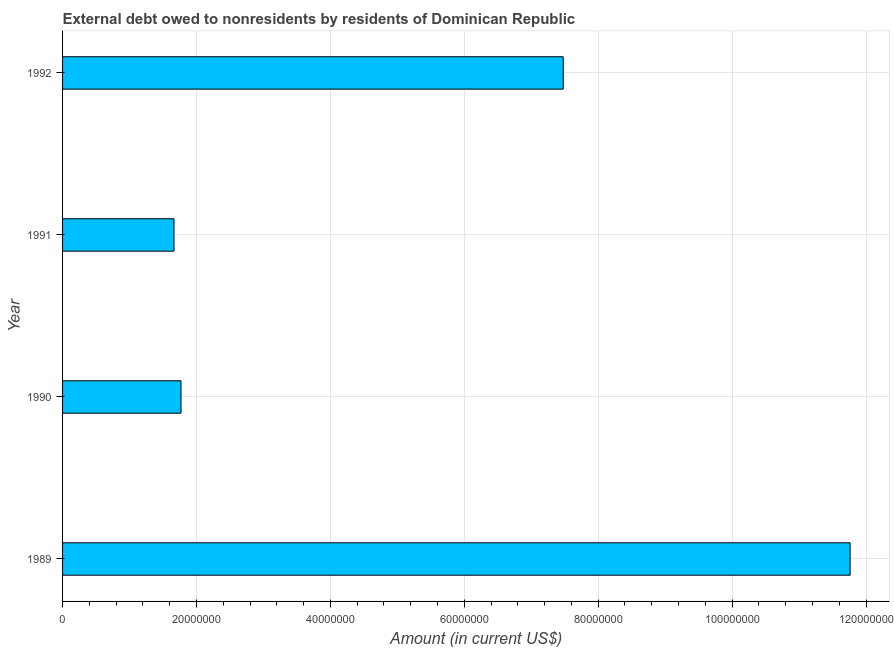Does the graph contain any zero values?
Offer a very short reply. No. Does the graph contain grids?
Offer a terse response. Yes. What is the title of the graph?
Offer a terse response. External debt owed to nonresidents by residents of Dominican Republic. What is the label or title of the X-axis?
Your answer should be compact. Amount (in current US$). What is the label or title of the Y-axis?
Provide a succinct answer. Year. What is the debt in 1989?
Your response must be concise. 1.18e+08. Across all years, what is the maximum debt?
Keep it short and to the point. 1.18e+08. Across all years, what is the minimum debt?
Your answer should be compact. 1.66e+07. What is the sum of the debt?
Keep it short and to the point. 2.27e+08. What is the difference between the debt in 1989 and 1990?
Provide a short and direct response. 9.99e+07. What is the average debt per year?
Your answer should be very brief. 5.67e+07. What is the median debt?
Provide a succinct answer. 4.62e+07. Do a majority of the years between 1990 and 1992 (inclusive) have debt greater than 28000000 US$?
Provide a short and direct response. No. What is the ratio of the debt in 1991 to that in 1992?
Your answer should be very brief. 0.22. What is the difference between the highest and the second highest debt?
Keep it short and to the point. 4.28e+07. What is the difference between the highest and the lowest debt?
Give a very brief answer. 1.01e+08. In how many years, is the debt greater than the average debt taken over all years?
Offer a very short reply. 2. How many bars are there?
Make the answer very short. 4. What is the difference between two consecutive major ticks on the X-axis?
Keep it short and to the point. 2.00e+07. What is the Amount (in current US$) in 1989?
Offer a terse response. 1.18e+08. What is the Amount (in current US$) of 1990?
Ensure brevity in your answer.  1.77e+07. What is the Amount (in current US$) of 1991?
Make the answer very short. 1.66e+07. What is the Amount (in current US$) in 1992?
Ensure brevity in your answer.  7.48e+07. What is the difference between the Amount (in current US$) in 1989 and 1990?
Your answer should be compact. 9.99e+07. What is the difference between the Amount (in current US$) in 1989 and 1991?
Offer a terse response. 1.01e+08. What is the difference between the Amount (in current US$) in 1989 and 1992?
Give a very brief answer. 4.28e+07. What is the difference between the Amount (in current US$) in 1990 and 1991?
Your response must be concise. 1.04e+06. What is the difference between the Amount (in current US$) in 1990 and 1992?
Your answer should be very brief. -5.71e+07. What is the difference between the Amount (in current US$) in 1991 and 1992?
Your response must be concise. -5.81e+07. What is the ratio of the Amount (in current US$) in 1989 to that in 1990?
Offer a very short reply. 6.65. What is the ratio of the Amount (in current US$) in 1989 to that in 1991?
Make the answer very short. 7.07. What is the ratio of the Amount (in current US$) in 1989 to that in 1992?
Your response must be concise. 1.57. What is the ratio of the Amount (in current US$) in 1990 to that in 1991?
Provide a succinct answer. 1.06. What is the ratio of the Amount (in current US$) in 1990 to that in 1992?
Provide a succinct answer. 0.24. What is the ratio of the Amount (in current US$) in 1991 to that in 1992?
Your answer should be compact. 0.22. 